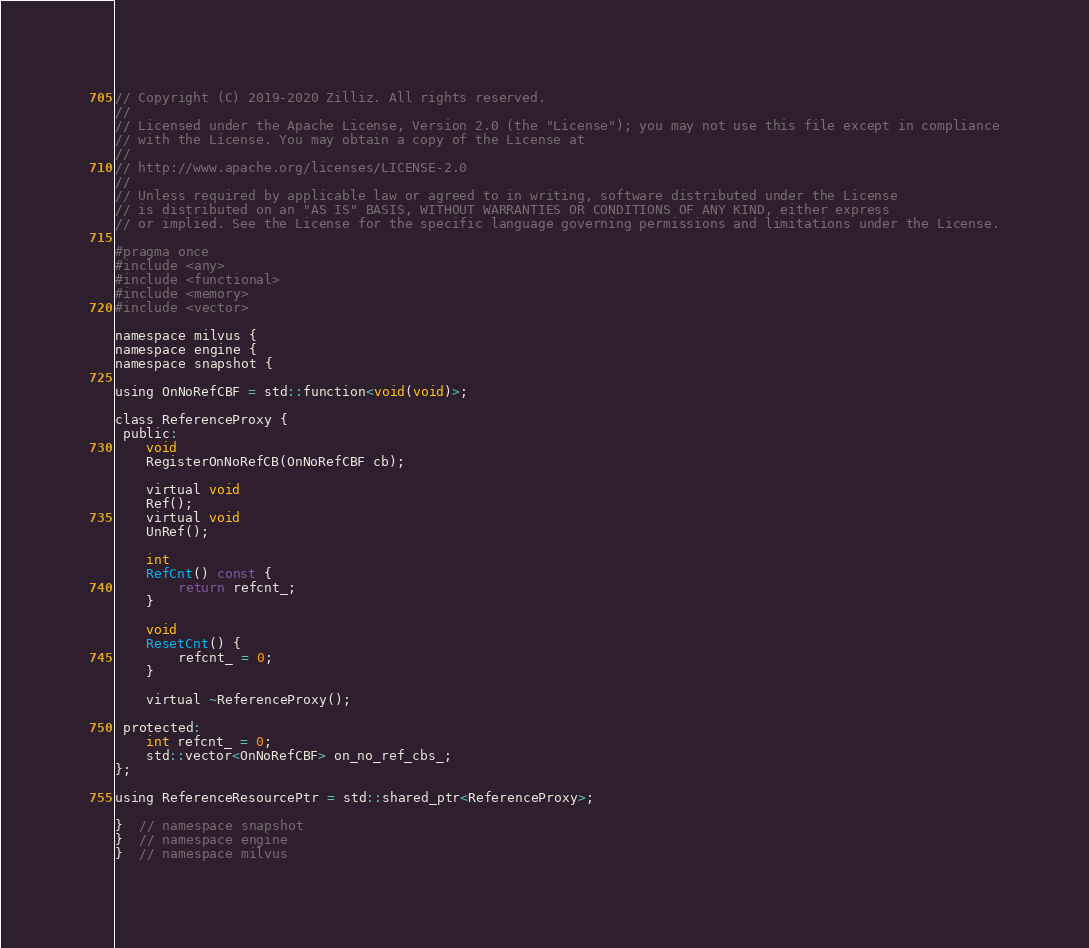Convert code to text. <code><loc_0><loc_0><loc_500><loc_500><_C_>// Copyright (C) 2019-2020 Zilliz. All rights reserved.
//
// Licensed under the Apache License, Version 2.0 (the "License"); you may not use this file except in compliance
// with the License. You may obtain a copy of the License at
//
// http://www.apache.org/licenses/LICENSE-2.0
//
// Unless required by applicable law or agreed to in writing, software distributed under the License
// is distributed on an "AS IS" BASIS, WITHOUT WARRANTIES OR CONDITIONS OF ANY KIND, either express
// or implied. See the License for the specific language governing permissions and limitations under the License.

#pragma once
#include <any>
#include <functional>
#include <memory>
#include <vector>

namespace milvus {
namespace engine {
namespace snapshot {

using OnNoRefCBF = std::function<void(void)>;

class ReferenceProxy {
 public:
    void
    RegisterOnNoRefCB(OnNoRefCBF cb);

    virtual void
    Ref();
    virtual void
    UnRef();

    int
    RefCnt() const {
        return refcnt_;
    }

    void
    ResetCnt() {
        refcnt_ = 0;
    }

    virtual ~ReferenceProxy();

 protected:
    int refcnt_ = 0;
    std::vector<OnNoRefCBF> on_no_ref_cbs_;
};

using ReferenceResourcePtr = std::shared_ptr<ReferenceProxy>;

}  // namespace snapshot
}  // namespace engine
}  // namespace milvus
</code> 